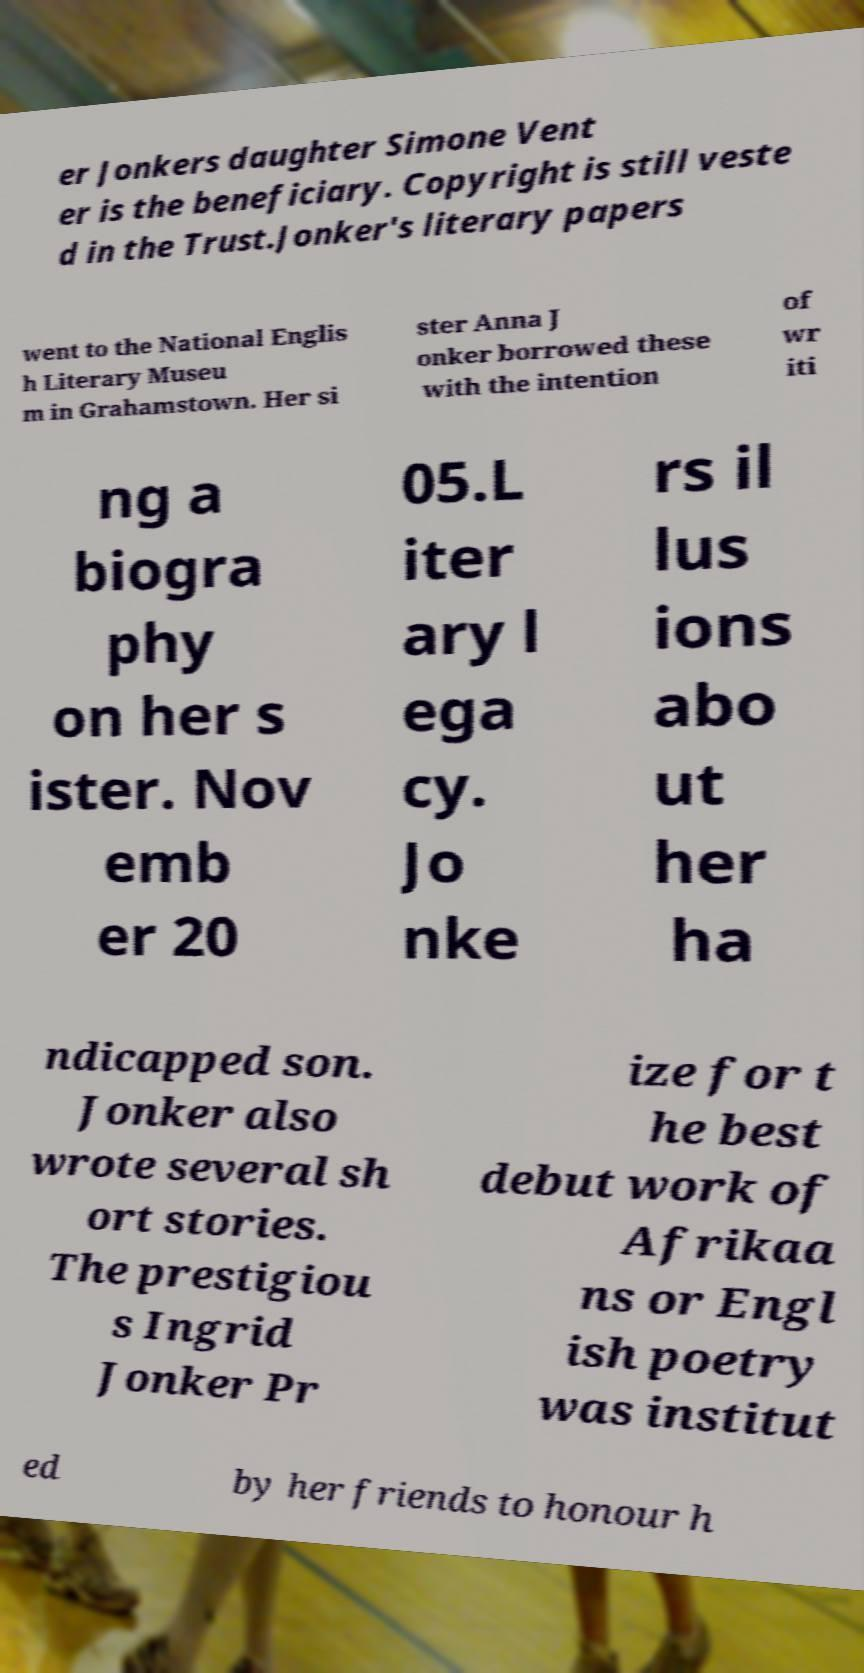Could you extract and type out the text from this image? er Jonkers daughter Simone Vent er is the beneficiary. Copyright is still veste d in the Trust.Jonker's literary papers went to the National Englis h Literary Museu m in Grahamstown. Her si ster Anna J onker borrowed these with the intention of wr iti ng a biogra phy on her s ister. Nov emb er 20 05.L iter ary l ega cy. Jo nke rs il lus ions abo ut her ha ndicapped son. Jonker also wrote several sh ort stories. The prestigiou s Ingrid Jonker Pr ize for t he best debut work of Afrikaa ns or Engl ish poetry was institut ed by her friends to honour h 